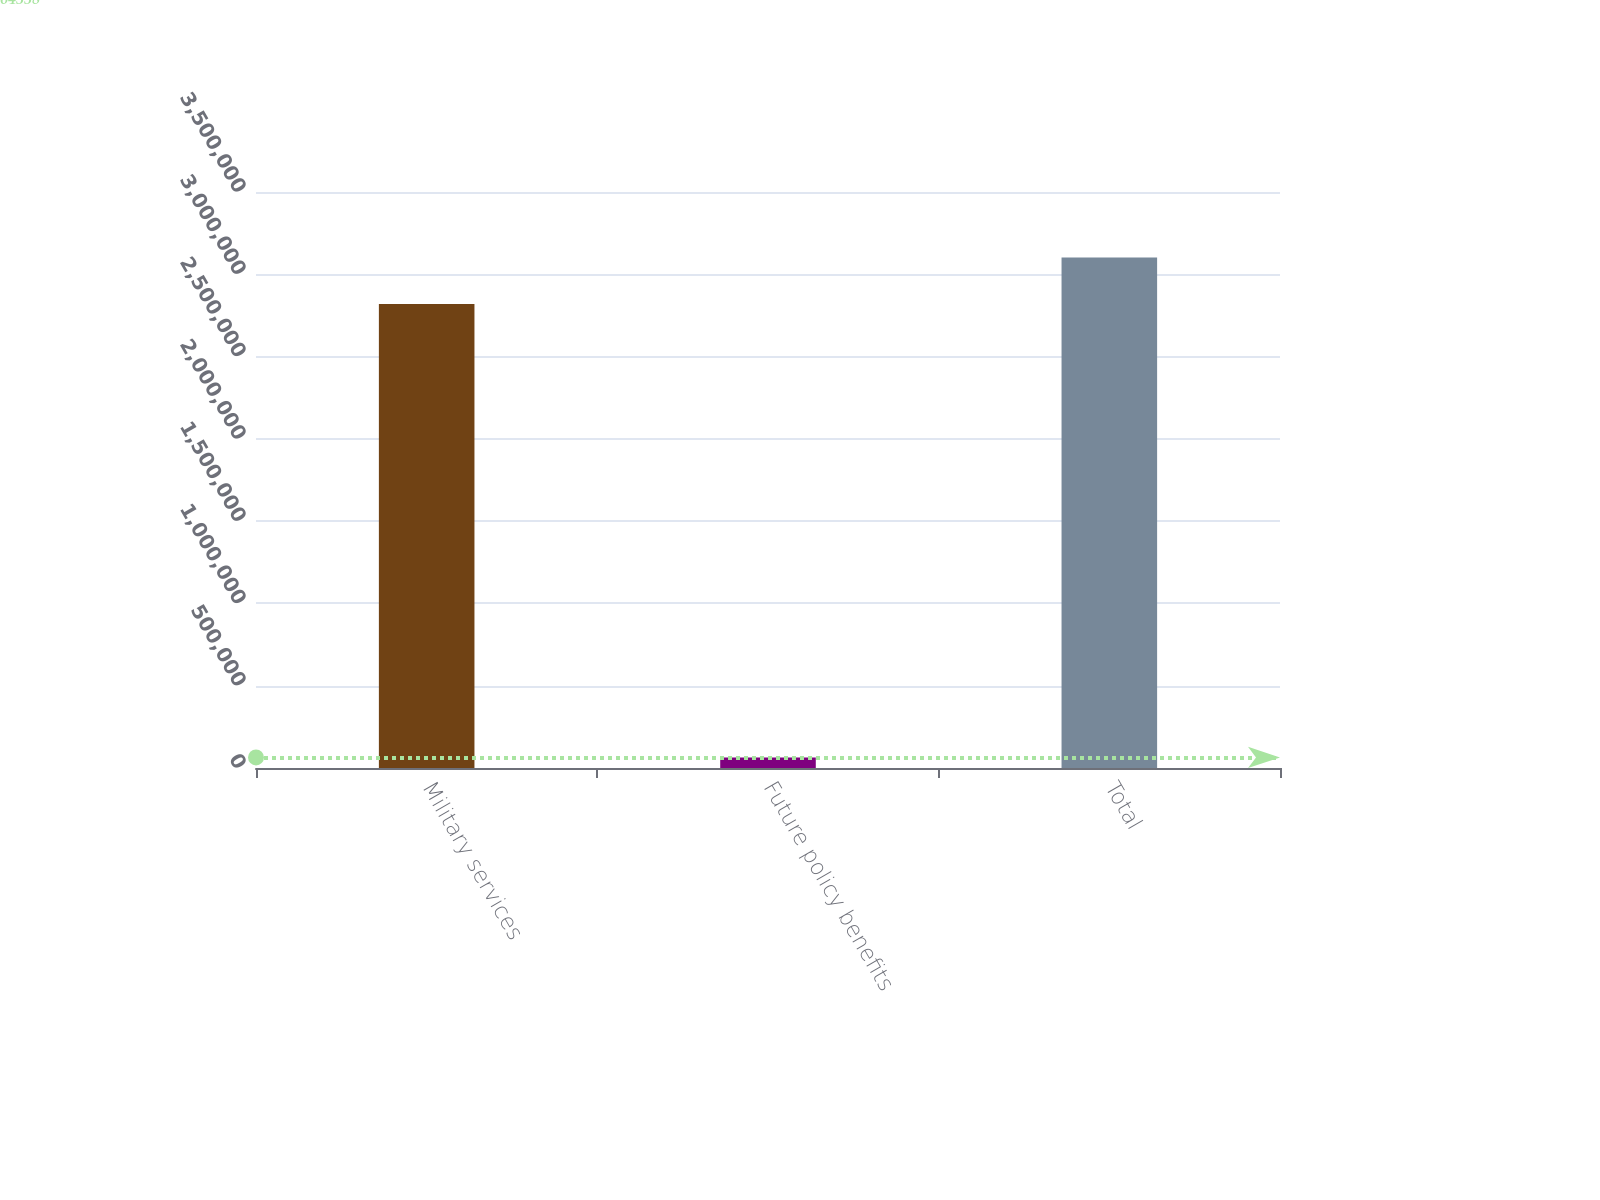Convert chart to OTSL. <chart><loc_0><loc_0><loc_500><loc_500><bar_chart><fcel>Military services<fcel>Future policy benefits<fcel>Total<nl><fcel>2.81979e+06<fcel>64338<fcel>3.10177e+06<nl></chart> 